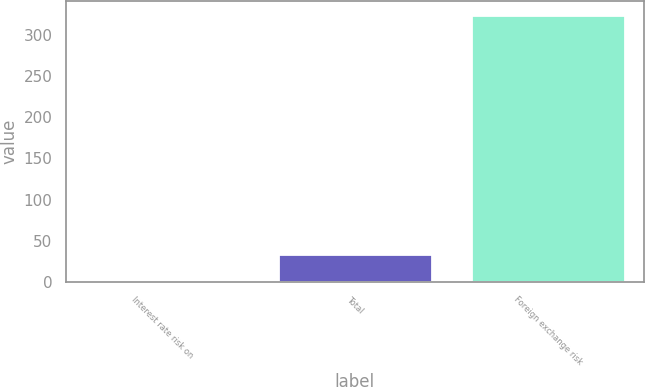<chart> <loc_0><loc_0><loc_500><loc_500><bar_chart><fcel>Interest rate risk on<fcel>Total<fcel>Foreign exchange risk<nl><fcel>1<fcel>33.4<fcel>325<nl></chart> 